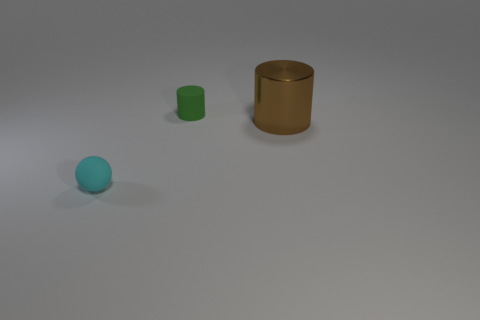There is a cylinder that is the same size as the cyan object; what is its material?
Make the answer very short. Rubber. What is the shape of the object that is both in front of the green cylinder and on the right side of the tiny rubber sphere?
Offer a very short reply. Cylinder. The matte thing that is the same size as the rubber cylinder is what color?
Your answer should be compact. Cyan. There is a matte thing in front of the large brown thing; is it the same size as the cylinder that is left of the brown shiny cylinder?
Provide a short and direct response. Yes. There is a rubber thing that is behind the matte thing in front of the small rubber thing that is behind the rubber ball; what is its size?
Your answer should be compact. Small. The tiny thing in front of the cylinder that is in front of the green rubber cylinder is what shape?
Keep it short and to the point. Sphere. The object that is on the left side of the shiny cylinder and behind the tiny cyan rubber sphere is what color?
Keep it short and to the point. Green. Are there any other tiny objects that have the same material as the small cyan thing?
Your response must be concise. Yes. The matte ball has what size?
Offer a very short reply. Small. What size is the rubber object that is in front of the tiny matte thing on the right side of the rubber ball?
Provide a short and direct response. Small. 